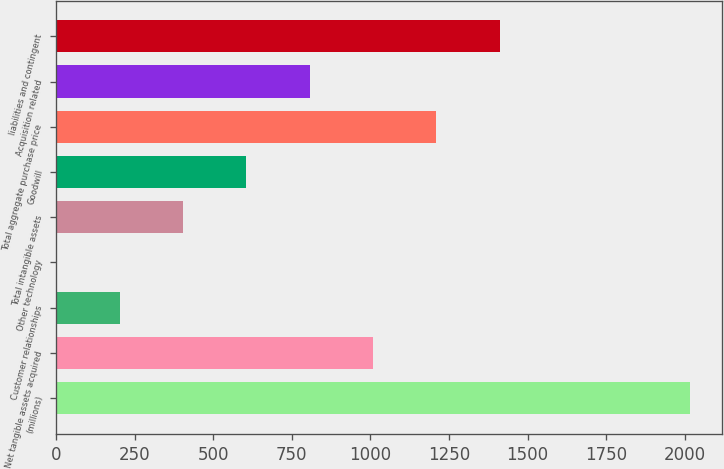Convert chart to OTSL. <chart><loc_0><loc_0><loc_500><loc_500><bar_chart><fcel>(millions)<fcel>Net tangible assets acquired<fcel>Customer relationships<fcel>Other technology<fcel>Total intangible assets<fcel>Goodwill<fcel>Total aggregate purchase price<fcel>Acquisition related<fcel>liabilities and contingent<nl><fcel>2016<fcel>1008.55<fcel>202.59<fcel>1.1<fcel>404.08<fcel>605.57<fcel>1210.04<fcel>807.06<fcel>1411.53<nl></chart> 